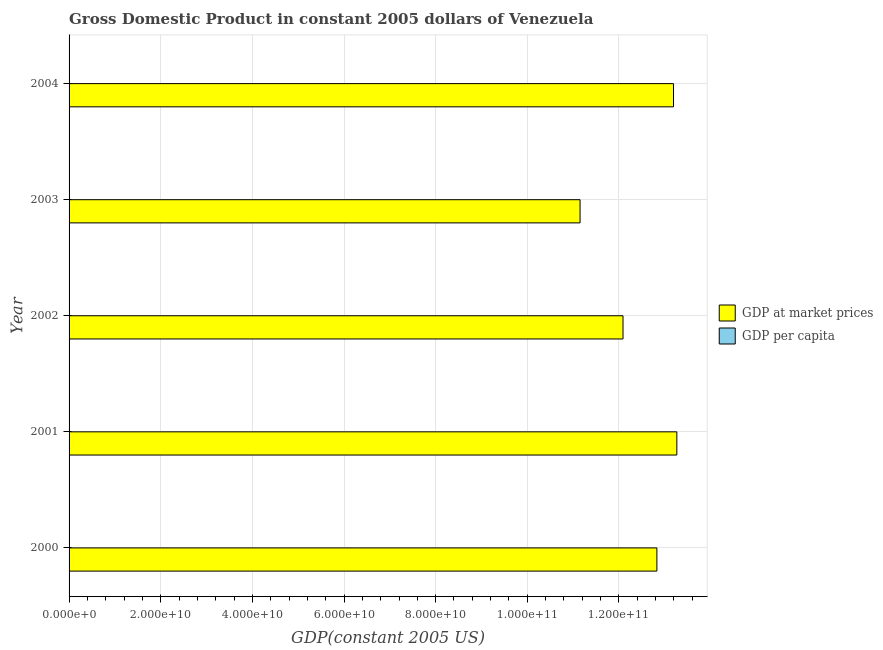How many different coloured bars are there?
Your answer should be very brief. 2. Are the number of bars per tick equal to the number of legend labels?
Your answer should be very brief. Yes. Are the number of bars on each tick of the Y-axis equal?
Your answer should be very brief. Yes. How many bars are there on the 2nd tick from the top?
Provide a succinct answer. 2. In how many cases, is the number of bars for a given year not equal to the number of legend labels?
Make the answer very short. 0. What is the gdp at market prices in 2000?
Make the answer very short. 1.28e+11. Across all years, what is the maximum gdp at market prices?
Offer a terse response. 1.33e+11. Across all years, what is the minimum gdp per capita?
Make the answer very short. 4312.55. What is the total gdp per capita in the graph?
Offer a very short reply. 2.46e+04. What is the difference between the gdp at market prices in 2003 and that in 2004?
Ensure brevity in your answer.  -2.04e+1. What is the difference between the gdp at market prices in 2003 and the gdp per capita in 2001?
Ensure brevity in your answer.  1.12e+11. What is the average gdp at market prices per year?
Make the answer very short. 1.25e+11. In the year 2000, what is the difference between the gdp at market prices and gdp per capita?
Make the answer very short. 1.28e+11. In how many years, is the gdp per capita greater than 108000000000 US$?
Provide a succinct answer. 0. What is the ratio of the gdp at market prices in 2002 to that in 2003?
Offer a very short reply. 1.08. What is the difference between the highest and the second highest gdp at market prices?
Ensure brevity in your answer.  7.29e+08. What is the difference between the highest and the lowest gdp per capita?
Your answer should be very brief. 1005.47. Is the sum of the gdp per capita in 2002 and 2003 greater than the maximum gdp at market prices across all years?
Your answer should be very brief. No. What does the 2nd bar from the top in 2004 represents?
Offer a very short reply. GDP at market prices. What does the 1st bar from the bottom in 2002 represents?
Your answer should be very brief. GDP at market prices. How many bars are there?
Offer a terse response. 10. Does the graph contain grids?
Offer a terse response. Yes. Where does the legend appear in the graph?
Keep it short and to the point. Center right. How many legend labels are there?
Provide a succinct answer. 2. What is the title of the graph?
Provide a short and direct response. Gross Domestic Product in constant 2005 dollars of Venezuela. Does "Broad money growth" appear as one of the legend labels in the graph?
Offer a very short reply. No. What is the label or title of the X-axis?
Offer a very short reply. GDP(constant 2005 US). What is the label or title of the Y-axis?
Make the answer very short. Year. What is the GDP(constant 2005 US) in GDP at market prices in 2000?
Your response must be concise. 1.28e+11. What is the GDP(constant 2005 US) of GDP per capita in 2000?
Provide a short and direct response. 5239.82. What is the GDP(constant 2005 US) of GDP at market prices in 2001?
Your answer should be compact. 1.33e+11. What is the GDP(constant 2005 US) in GDP per capita in 2001?
Offer a terse response. 5318.02. What is the GDP(constant 2005 US) of GDP at market prices in 2002?
Provide a short and direct response. 1.21e+11. What is the GDP(constant 2005 US) in GDP per capita in 2002?
Provide a succinct answer. 4759.5. What is the GDP(constant 2005 US) of GDP at market prices in 2003?
Keep it short and to the point. 1.12e+11. What is the GDP(constant 2005 US) of GDP per capita in 2003?
Keep it short and to the point. 4312.55. What is the GDP(constant 2005 US) of GDP at market prices in 2004?
Offer a terse response. 1.32e+11. What is the GDP(constant 2005 US) of GDP per capita in 2004?
Provide a short and direct response. 5012.59. Across all years, what is the maximum GDP(constant 2005 US) in GDP at market prices?
Your response must be concise. 1.33e+11. Across all years, what is the maximum GDP(constant 2005 US) of GDP per capita?
Keep it short and to the point. 5318.02. Across all years, what is the minimum GDP(constant 2005 US) in GDP at market prices?
Give a very brief answer. 1.12e+11. Across all years, what is the minimum GDP(constant 2005 US) in GDP per capita?
Offer a terse response. 4312.55. What is the total GDP(constant 2005 US) of GDP at market prices in the graph?
Make the answer very short. 6.25e+11. What is the total GDP(constant 2005 US) of GDP per capita in the graph?
Provide a succinct answer. 2.46e+04. What is the difference between the GDP(constant 2005 US) in GDP at market prices in 2000 and that in 2001?
Your answer should be very brief. -4.35e+09. What is the difference between the GDP(constant 2005 US) in GDP per capita in 2000 and that in 2001?
Your answer should be very brief. -78.2. What is the difference between the GDP(constant 2005 US) in GDP at market prices in 2000 and that in 2002?
Give a very brief answer. 7.39e+09. What is the difference between the GDP(constant 2005 US) in GDP per capita in 2000 and that in 2002?
Give a very brief answer. 480.32. What is the difference between the GDP(constant 2005 US) of GDP at market prices in 2000 and that in 2003?
Offer a very short reply. 1.68e+1. What is the difference between the GDP(constant 2005 US) in GDP per capita in 2000 and that in 2003?
Your response must be concise. 927.27. What is the difference between the GDP(constant 2005 US) of GDP at market prices in 2000 and that in 2004?
Your answer should be very brief. -3.63e+09. What is the difference between the GDP(constant 2005 US) of GDP per capita in 2000 and that in 2004?
Provide a succinct answer. 227.23. What is the difference between the GDP(constant 2005 US) of GDP at market prices in 2001 and that in 2002?
Provide a short and direct response. 1.17e+1. What is the difference between the GDP(constant 2005 US) of GDP per capita in 2001 and that in 2002?
Keep it short and to the point. 558.52. What is the difference between the GDP(constant 2005 US) in GDP at market prices in 2001 and that in 2003?
Ensure brevity in your answer.  2.11e+1. What is the difference between the GDP(constant 2005 US) of GDP per capita in 2001 and that in 2003?
Your answer should be compact. 1005.47. What is the difference between the GDP(constant 2005 US) in GDP at market prices in 2001 and that in 2004?
Provide a short and direct response. 7.29e+08. What is the difference between the GDP(constant 2005 US) in GDP per capita in 2001 and that in 2004?
Ensure brevity in your answer.  305.43. What is the difference between the GDP(constant 2005 US) in GDP at market prices in 2002 and that in 2003?
Your answer should be very brief. 9.38e+09. What is the difference between the GDP(constant 2005 US) of GDP per capita in 2002 and that in 2003?
Provide a succinct answer. 446.95. What is the difference between the GDP(constant 2005 US) of GDP at market prices in 2002 and that in 2004?
Keep it short and to the point. -1.10e+1. What is the difference between the GDP(constant 2005 US) in GDP per capita in 2002 and that in 2004?
Provide a short and direct response. -253.09. What is the difference between the GDP(constant 2005 US) of GDP at market prices in 2003 and that in 2004?
Offer a very short reply. -2.04e+1. What is the difference between the GDP(constant 2005 US) in GDP per capita in 2003 and that in 2004?
Offer a very short reply. -700.04. What is the difference between the GDP(constant 2005 US) in GDP at market prices in 2000 and the GDP(constant 2005 US) in GDP per capita in 2001?
Offer a very short reply. 1.28e+11. What is the difference between the GDP(constant 2005 US) in GDP at market prices in 2000 and the GDP(constant 2005 US) in GDP per capita in 2002?
Your answer should be very brief. 1.28e+11. What is the difference between the GDP(constant 2005 US) of GDP at market prices in 2000 and the GDP(constant 2005 US) of GDP per capita in 2003?
Ensure brevity in your answer.  1.28e+11. What is the difference between the GDP(constant 2005 US) in GDP at market prices in 2000 and the GDP(constant 2005 US) in GDP per capita in 2004?
Make the answer very short. 1.28e+11. What is the difference between the GDP(constant 2005 US) in GDP at market prices in 2001 and the GDP(constant 2005 US) in GDP per capita in 2002?
Ensure brevity in your answer.  1.33e+11. What is the difference between the GDP(constant 2005 US) of GDP at market prices in 2001 and the GDP(constant 2005 US) of GDP per capita in 2003?
Give a very brief answer. 1.33e+11. What is the difference between the GDP(constant 2005 US) in GDP at market prices in 2001 and the GDP(constant 2005 US) in GDP per capita in 2004?
Provide a succinct answer. 1.33e+11. What is the difference between the GDP(constant 2005 US) of GDP at market prices in 2002 and the GDP(constant 2005 US) of GDP per capita in 2003?
Offer a very short reply. 1.21e+11. What is the difference between the GDP(constant 2005 US) of GDP at market prices in 2002 and the GDP(constant 2005 US) of GDP per capita in 2004?
Keep it short and to the point. 1.21e+11. What is the difference between the GDP(constant 2005 US) of GDP at market prices in 2003 and the GDP(constant 2005 US) of GDP per capita in 2004?
Make the answer very short. 1.12e+11. What is the average GDP(constant 2005 US) in GDP at market prices per year?
Ensure brevity in your answer.  1.25e+11. What is the average GDP(constant 2005 US) in GDP per capita per year?
Your answer should be compact. 4928.5. In the year 2000, what is the difference between the GDP(constant 2005 US) in GDP at market prices and GDP(constant 2005 US) in GDP per capita?
Your answer should be compact. 1.28e+11. In the year 2001, what is the difference between the GDP(constant 2005 US) in GDP at market prices and GDP(constant 2005 US) in GDP per capita?
Keep it short and to the point. 1.33e+11. In the year 2002, what is the difference between the GDP(constant 2005 US) in GDP at market prices and GDP(constant 2005 US) in GDP per capita?
Give a very brief answer. 1.21e+11. In the year 2003, what is the difference between the GDP(constant 2005 US) in GDP at market prices and GDP(constant 2005 US) in GDP per capita?
Offer a very short reply. 1.12e+11. In the year 2004, what is the difference between the GDP(constant 2005 US) of GDP at market prices and GDP(constant 2005 US) of GDP per capita?
Give a very brief answer. 1.32e+11. What is the ratio of the GDP(constant 2005 US) in GDP at market prices in 2000 to that in 2001?
Offer a very short reply. 0.97. What is the ratio of the GDP(constant 2005 US) in GDP at market prices in 2000 to that in 2002?
Your answer should be very brief. 1.06. What is the ratio of the GDP(constant 2005 US) of GDP per capita in 2000 to that in 2002?
Your answer should be compact. 1.1. What is the ratio of the GDP(constant 2005 US) of GDP at market prices in 2000 to that in 2003?
Ensure brevity in your answer.  1.15. What is the ratio of the GDP(constant 2005 US) in GDP per capita in 2000 to that in 2003?
Your answer should be compact. 1.22. What is the ratio of the GDP(constant 2005 US) in GDP at market prices in 2000 to that in 2004?
Keep it short and to the point. 0.97. What is the ratio of the GDP(constant 2005 US) of GDP per capita in 2000 to that in 2004?
Your answer should be compact. 1.05. What is the ratio of the GDP(constant 2005 US) of GDP at market prices in 2001 to that in 2002?
Make the answer very short. 1.1. What is the ratio of the GDP(constant 2005 US) in GDP per capita in 2001 to that in 2002?
Ensure brevity in your answer.  1.12. What is the ratio of the GDP(constant 2005 US) in GDP at market prices in 2001 to that in 2003?
Provide a short and direct response. 1.19. What is the ratio of the GDP(constant 2005 US) in GDP per capita in 2001 to that in 2003?
Your answer should be very brief. 1.23. What is the ratio of the GDP(constant 2005 US) in GDP per capita in 2001 to that in 2004?
Your answer should be compact. 1.06. What is the ratio of the GDP(constant 2005 US) of GDP at market prices in 2002 to that in 2003?
Offer a very short reply. 1.08. What is the ratio of the GDP(constant 2005 US) of GDP per capita in 2002 to that in 2003?
Your answer should be compact. 1.1. What is the ratio of the GDP(constant 2005 US) in GDP at market prices in 2002 to that in 2004?
Your answer should be compact. 0.92. What is the ratio of the GDP(constant 2005 US) of GDP per capita in 2002 to that in 2004?
Provide a succinct answer. 0.95. What is the ratio of the GDP(constant 2005 US) of GDP at market prices in 2003 to that in 2004?
Provide a short and direct response. 0.85. What is the ratio of the GDP(constant 2005 US) of GDP per capita in 2003 to that in 2004?
Offer a terse response. 0.86. What is the difference between the highest and the second highest GDP(constant 2005 US) in GDP at market prices?
Your answer should be very brief. 7.29e+08. What is the difference between the highest and the second highest GDP(constant 2005 US) in GDP per capita?
Provide a short and direct response. 78.2. What is the difference between the highest and the lowest GDP(constant 2005 US) of GDP at market prices?
Ensure brevity in your answer.  2.11e+1. What is the difference between the highest and the lowest GDP(constant 2005 US) of GDP per capita?
Provide a succinct answer. 1005.47. 